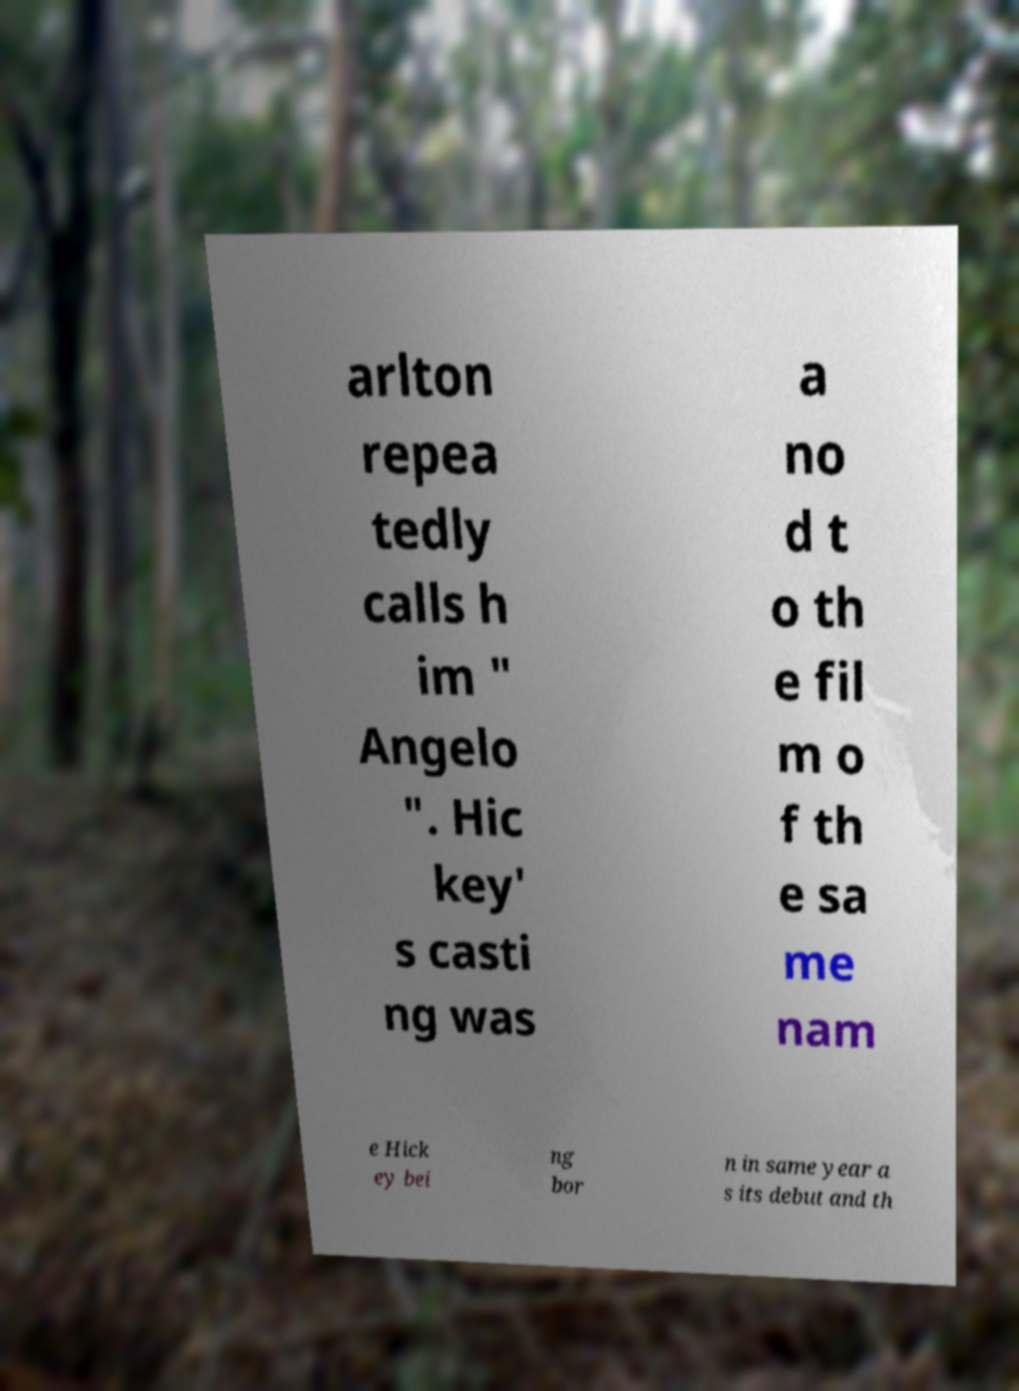What messages or text are displayed in this image? I need them in a readable, typed format. arlton repea tedly calls h im " Angelo ". Hic key' s casti ng was a no d t o th e fil m o f th e sa me nam e Hick ey bei ng bor n in same year a s its debut and th 